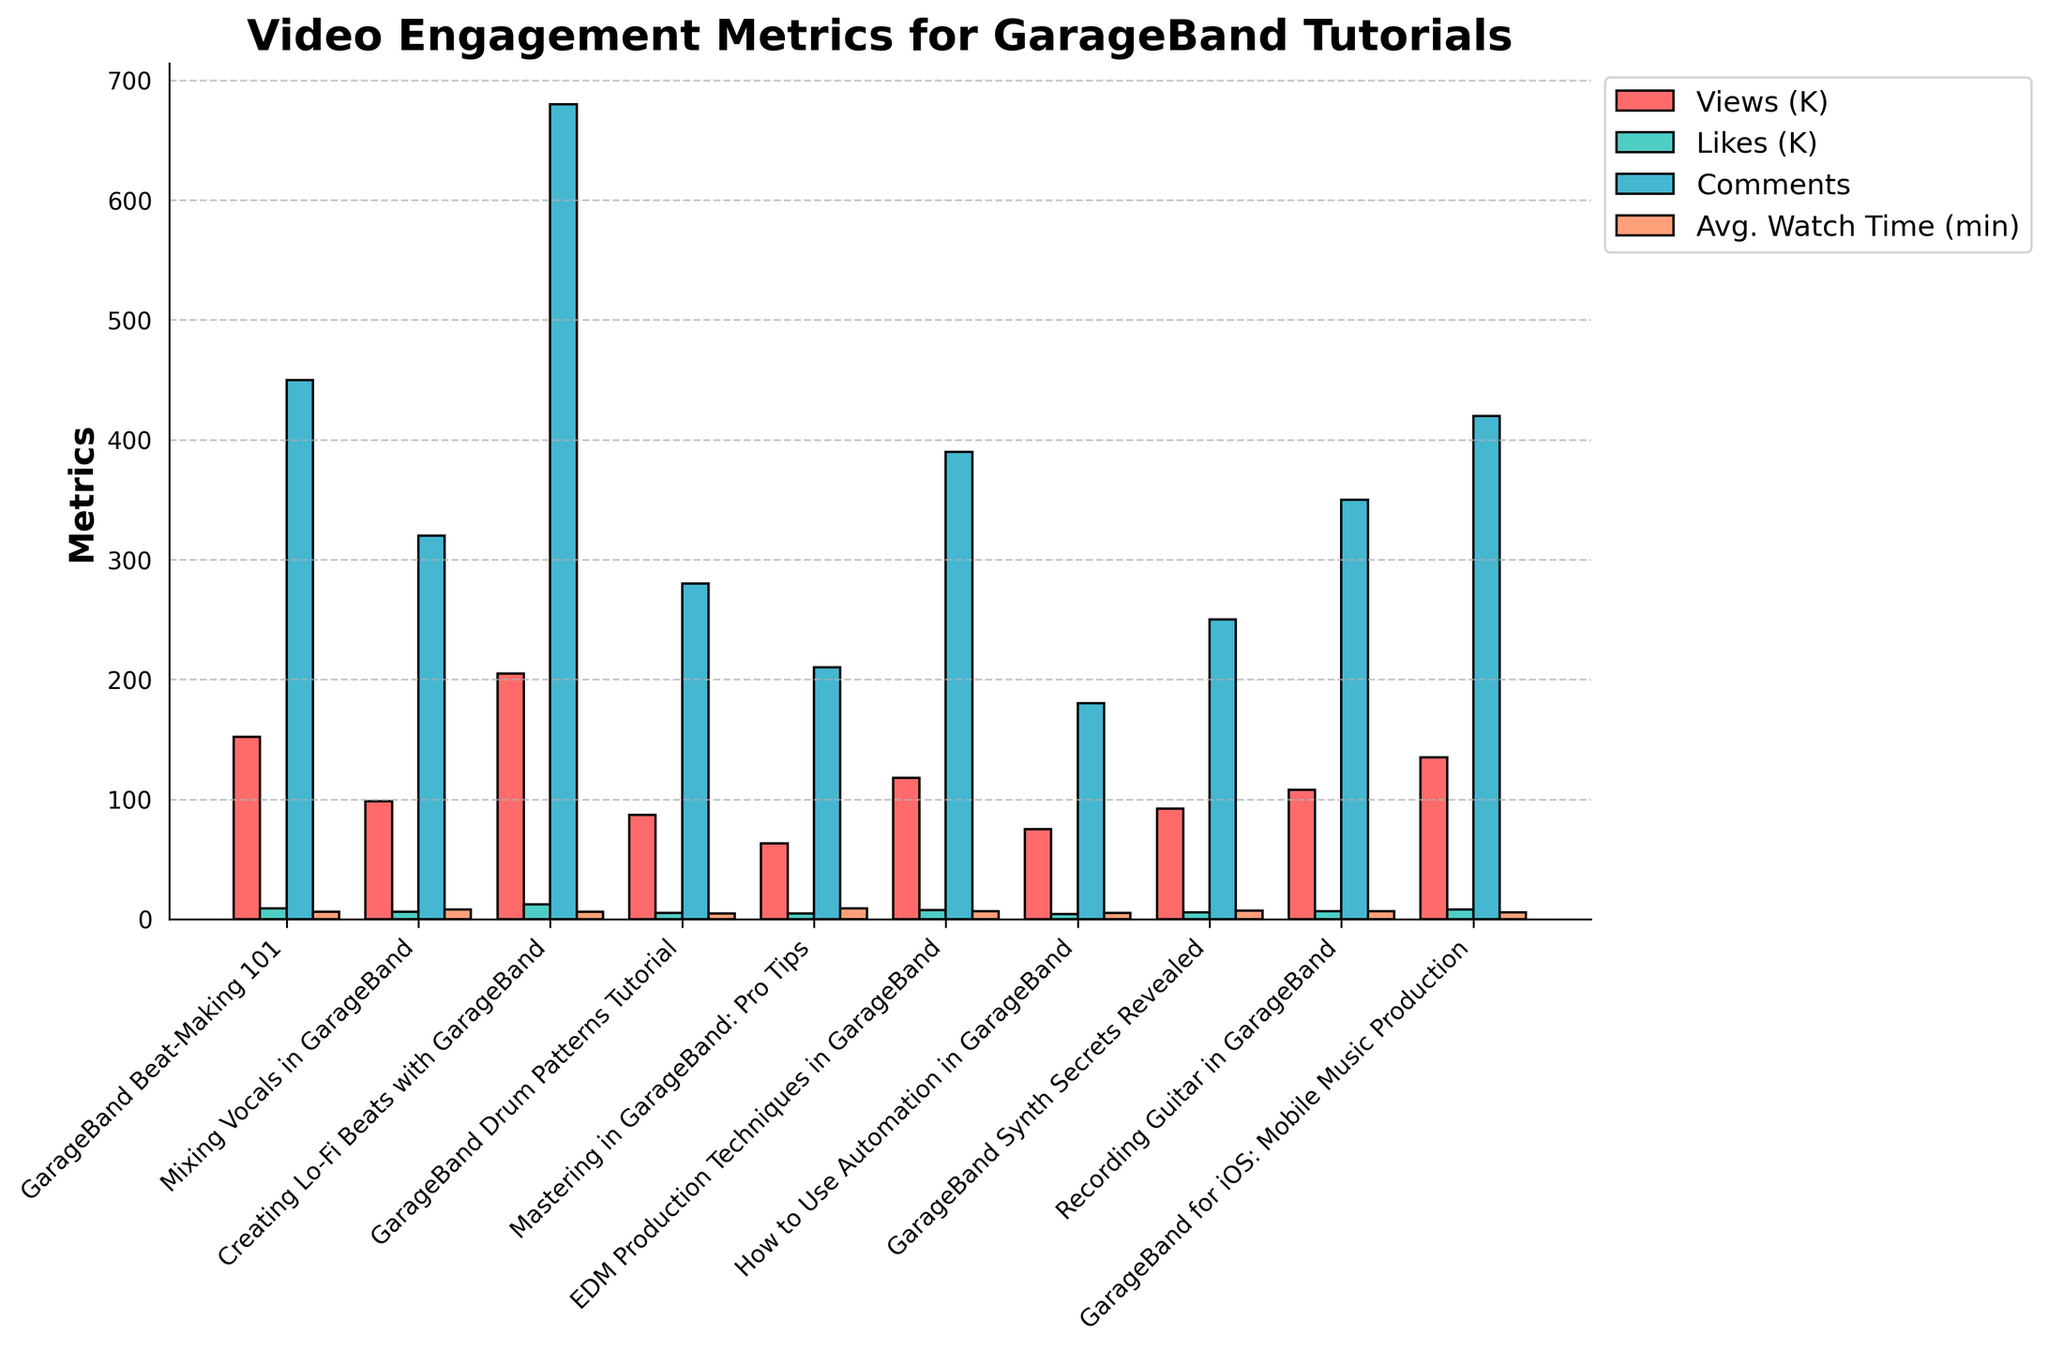Which video has the highest number of views? Find the bar with the greatest height in the "Views (K)" category, which is labeled "**Creating Lo-Fi Beats with GarageBand**".
Answer: **Creating Lo-Fi Beats with GarageBand** Which video shows the highest average watch time? Locate the tallest bar in the "Avg. Watch Time (min)" category. "**Mastering in GarageBand: Pro Tips**" has the highest value.
Answer: **Mastering in GarageBand: Pro Tips** What is the total number of comments for all videos? Sum the values of all the bars in the "Comments" category: 450 + 320 + 680 + 280 + 210 + 390 + 180 + 250 + 350 + 420 = 3530.
Answer: **3530** Which video has received more likes than views (in thousands)? Compare the height of the bars for "Likes (K)" and "Views (K)" for each video. None of the videos show "Likes (K)" exceeding their "Views (K)".
Answer: **None** Which video has the lowest view count? Identify the bar with the smallest height in the "Views (K)" category. "**Mastering in GarageBand: Pro Tips**" has the smallest value.
Answer: **Mastering in GarageBand: Pro Tips** Which two videos have the closest average watch times? Compare the heights of bars in the "Avg. Watch Time (min)" category to judge similarity. "**Mixing Vocals in GarageBand**" and "**GarageBand Synth Secrets Revealed**" both have close heights, indicating similar average watch times (7.8 and 7.2 respectively).
Answer: **Mixing Vocals in GarageBand** and **GarageBand Synth Secrets Revealed** Is there any video with views below 100K but with likes above 5K? If yes, which one? Check the "Views (K)" and "Likes (K)" categories together to see if there's a bar for views less than 100K alongside a bar for likes above 5K. "**Mixing Vocals in GarageBand**" has 98.5K views and 6.2K likes.
Answer: **Mixing Vocals in GarageBand** Which had a bigger difference between views and likes, "EDM Production Techniques in GarageBand" or "GarageBand for iOS: Mobile Music Production"? Calculate the difference between the "Views (K)" and "Likes (K)" values for both videos. "EDM Production Techniques in GarageBand" has 118K - 7.5K = 110.5K and "GarageBand for iOS: Mobile Music Production" has 135K - 7.9K = 127.1K. The latter has the bigger difference.
Answer: **GarageBand for iOS: Mobile Music Production** 